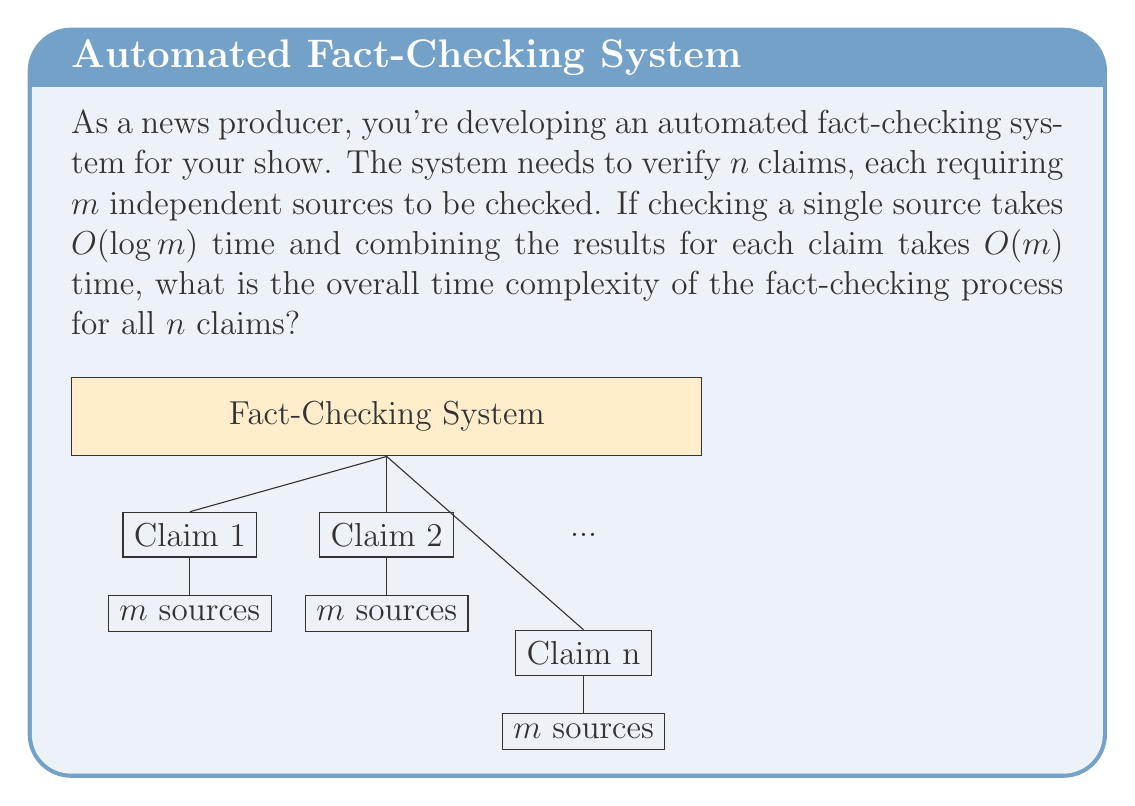Help me with this question. Let's break down the problem and analyze it step by step:

1) For each claim, we need to check $m$ independent sources.

2) Checking a single source takes $O(\log m)$ time.

3) For one claim, checking all $m$ sources would take:
   $O(m \cdot \log m)$ time

4) After checking all sources for a claim, combining the results takes $O(m)$ time.

5) So, the total time for processing one claim is:
   $O(m \cdot \log m + m) = O(m \cdot \log m)$
   (We can drop the $O(m)$ term as it's dominated by $O(m \cdot \log m)$)

6) We need to repeat this process for all $n$ claims.

7) Therefore, the total time complexity for all $n$ claims is:
   $O(n \cdot m \cdot \log m)$

This time complexity represents the worst-case scenario for the fact-checking system, where all $n$ claims require checking $m$ sources each.
Answer: $O(n \cdot m \cdot \log m)$ 